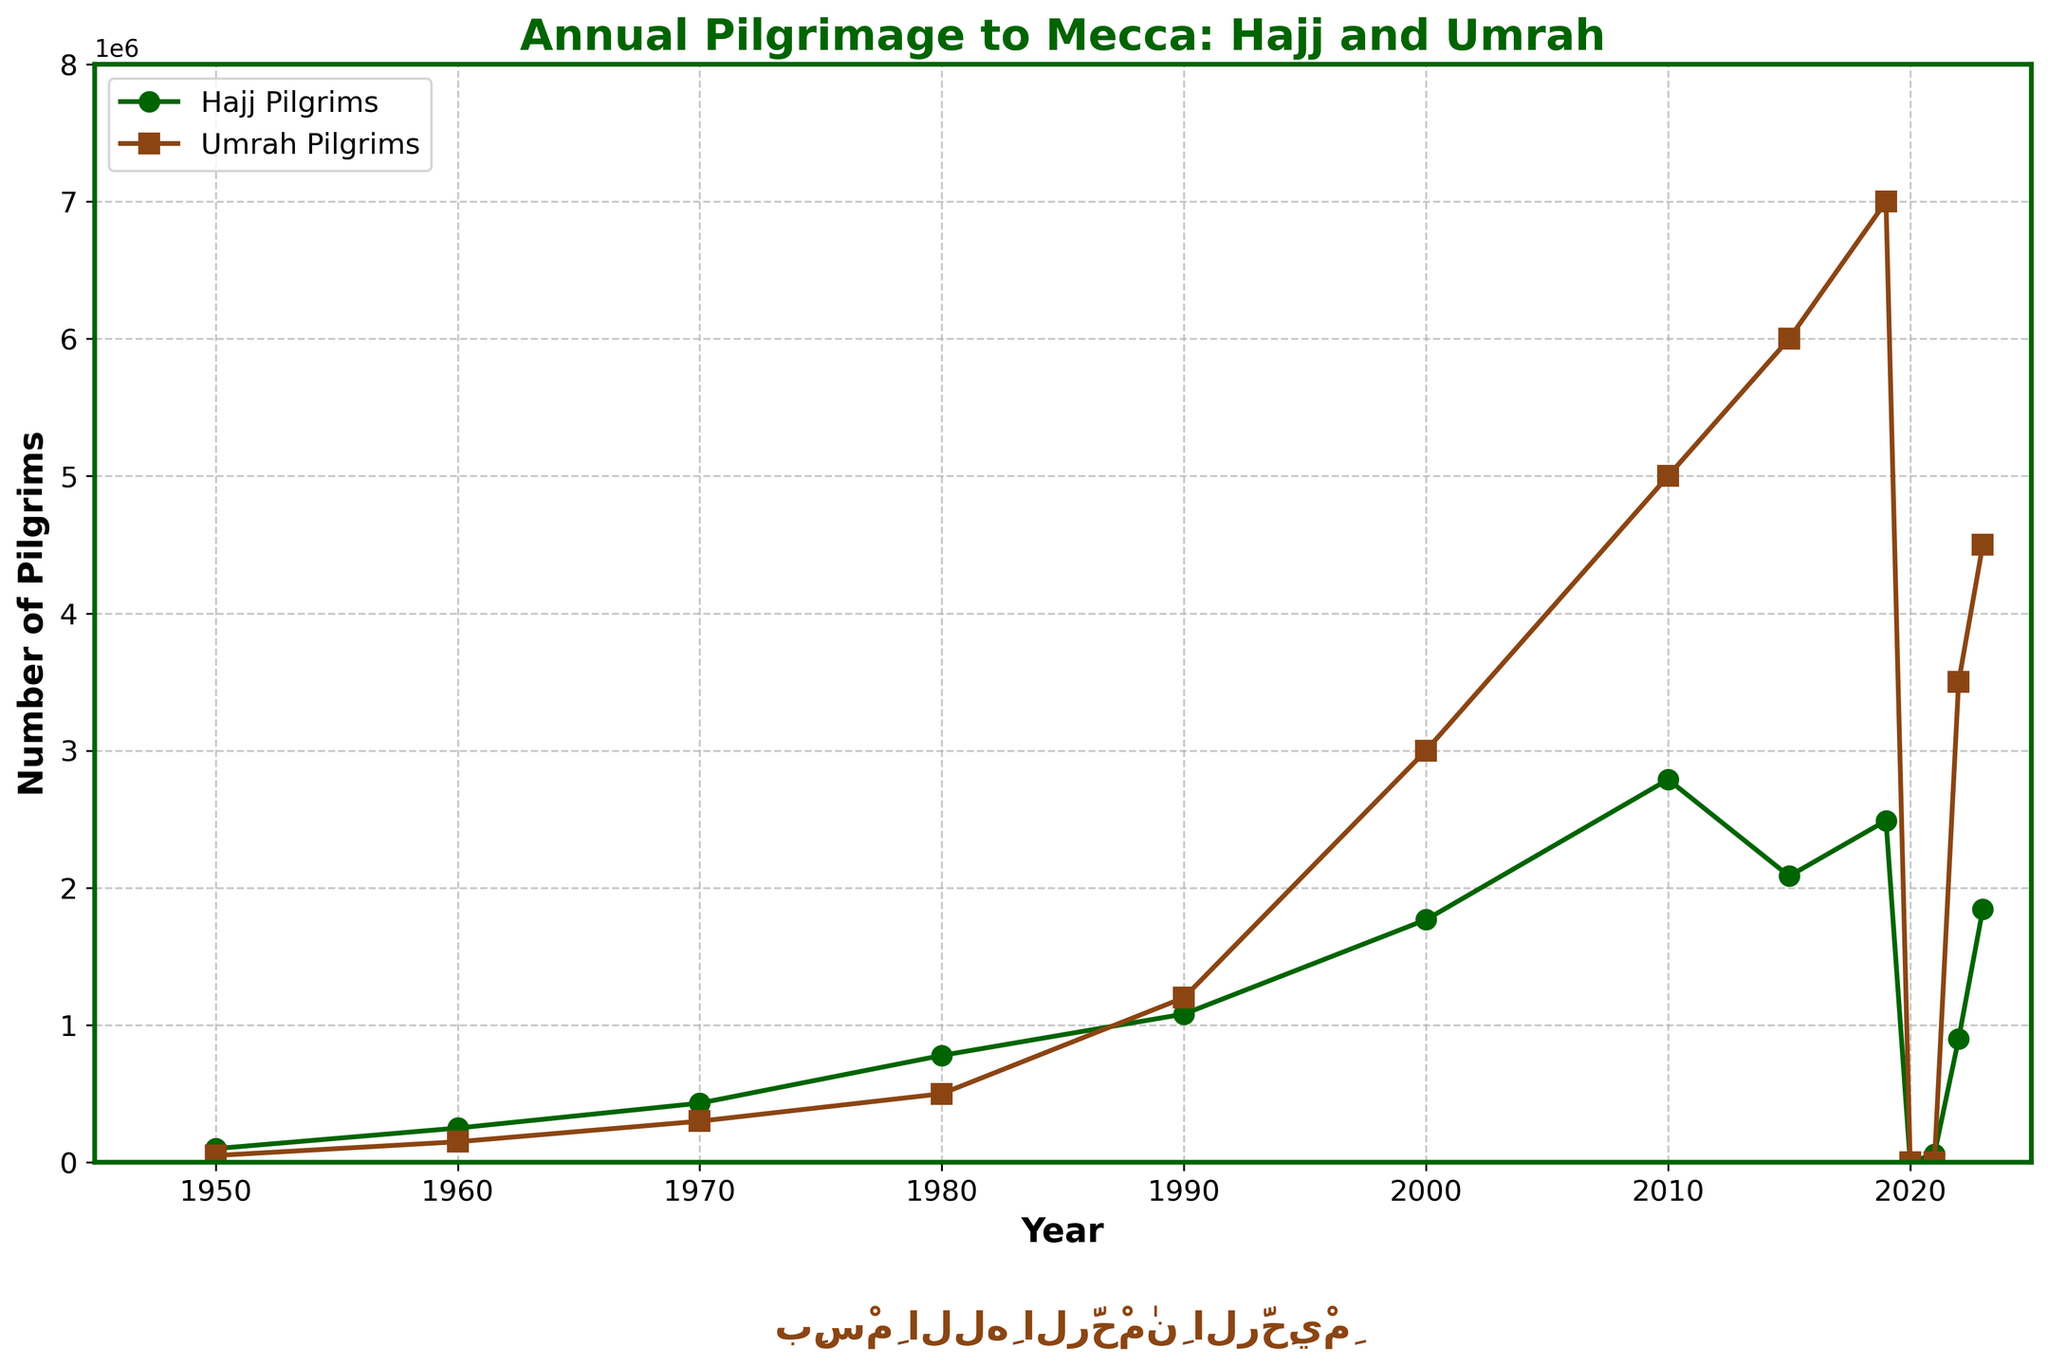What was the highest number of Hajj pilgrims recorded? The figure shows the number of Hajj pilgrims for each year. The highest marker on the Hajj line gives the highest number of pilgrims.
Answer: 2789399 Which year saw a dramatic decrease in the number of Hajj pilgrims? Observing the Hajj pilgrims' line, the largest drop is between 2019 and 2020, where the markers go from a high point to nearly touching the x-axis.
Answer: 2020 How many years had the number of Umrah pilgrims equal to zero? The line representing the Umrah pilgrims dips to the x-axis in consecutive years representing zero pilgrims. Count these points.
Answer: 2 years (2020, 2021) In which year was the difference between the number of Hajj and Umrah pilgrims the greatest? Calculate the difference for each year by subtracting 'Hajj Pilgrims' from 'Umrah Pilgrims'. The year with the highest difference is evident.
Answer: 2010 What was the trend in the number of Umrah pilgrims from 1950 to 2019? Follow the line for Umrah pilgrims from 1950 to 2019 and observe whether it increases, decreases, or fluctuates.
Answer: Increasing Compare the number of pilgrims for Hajj and Umrah in 2023. Which was higher? Refer to the 2023 data points for both Hajj and Umrah pilgrims and compare their heights.
Answer: Umrah pilgrims What visual elements distinguish the Hajj and Umrah lines in the plot? The colors, markers, and line styles provide visual distinctions. Hajj is represented with circles and a particular color, and Umrah with squares and another color.
Answer: Color and markers Which year had the closest number of Hajj and Umrah pilgrims? Look for years where the Hajj and Umrah lines are closest to each other vertically.
Answer: 1970 How many times did the number of Hajj pilgrims exceed 1 million? Count the years where the data point for Hajj pilgrims crosses the 1 million mark.
Answer: 8 times What is the general trend for Hajj pilgrims from 1950 to 2023? Observe the slope and direction of the line representing Hajj pilgrims overall from 1950 to 2023.
Answer: Increasing with fluctuations 